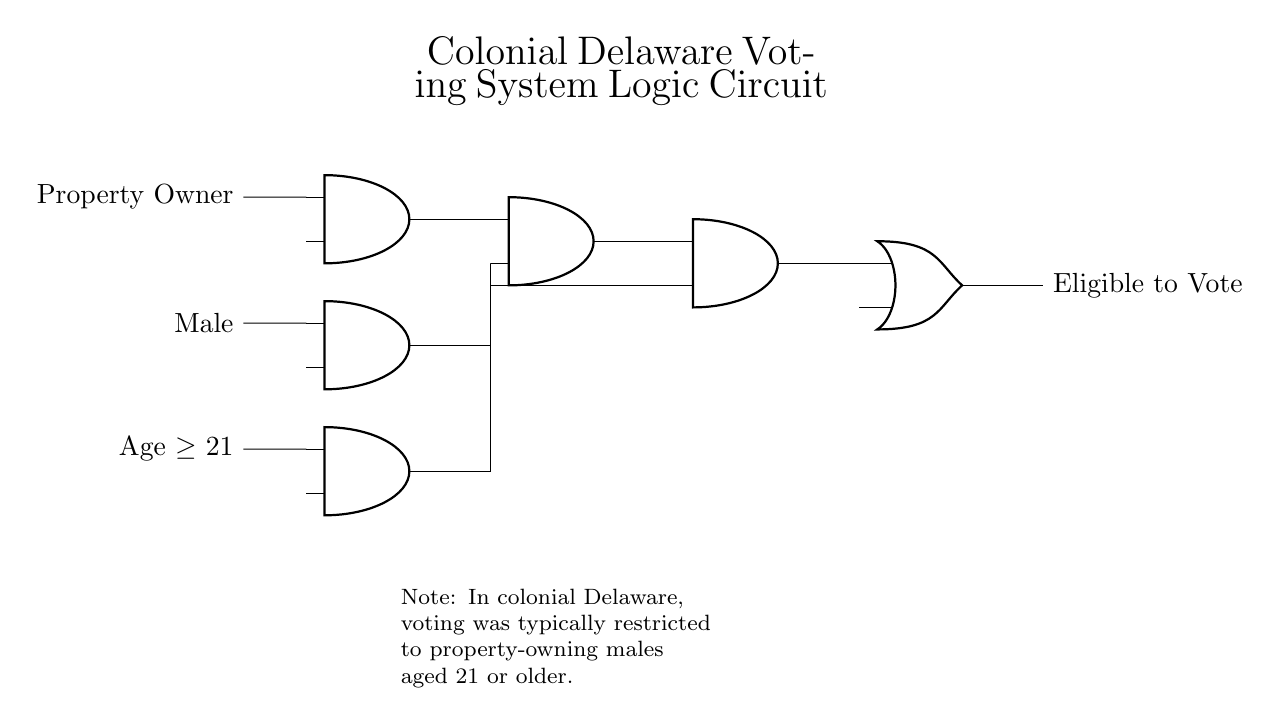What are the inputs to this circuit? The inputs are "Property Owner," "Male," and "Age greater than or equal to 21," as indicated by the labels next to the ports on the left side of the circuit.
Answer: Property Owner, Male, Age greater than or equal to 21 What type of logic gates are used in this circuit? This circuit contains AND gates and an OR gate. The AND gates combine the conditions for eligibility, while the final output is determined by the OR gate.
Answer: AND and OR gates How many conditions must be satisfied for someone to be eligible to vote? The circuit shows three conditions: one for property ownership, one for gender, and one for age, meaning all three conditions must be satisfied, as represented by the AND gates connected in series.
Answer: Three conditions What is the output of the circuit? The output of the circuit is labeled as "Eligible to Vote," which is determined by the conditions satisfied through the input logic gates.
Answer: Eligible to Vote Explain how the voting eligibility is determined in this circuit. The circuit requires all three inputs to be true (property ownership, being male, and being at least 21 years old) to output "Eligible to Vote." The AND gates ensure that all conditions must be met to produce a positive outcome, while the OR gate indicates the result of those conditions. If any input is false, the output will not indicate eligibility.
Answer: By requiring all three inputs to be true What does the AND gate represent in the context of voting eligibility? Each AND gate represents a requirement that must be met for a voter to qualify. For example, the first AND gate ensures both property ownership and gender are satisfied, which must then be satisfied together with age in the next AND gate for eligibility.
Answer: Requirements for qualification 